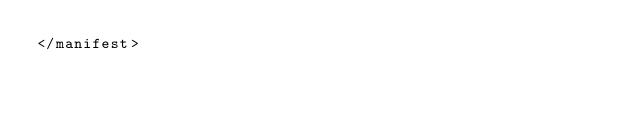Convert code to text. <code><loc_0><loc_0><loc_500><loc_500><_XML_></manifest>
</code> 